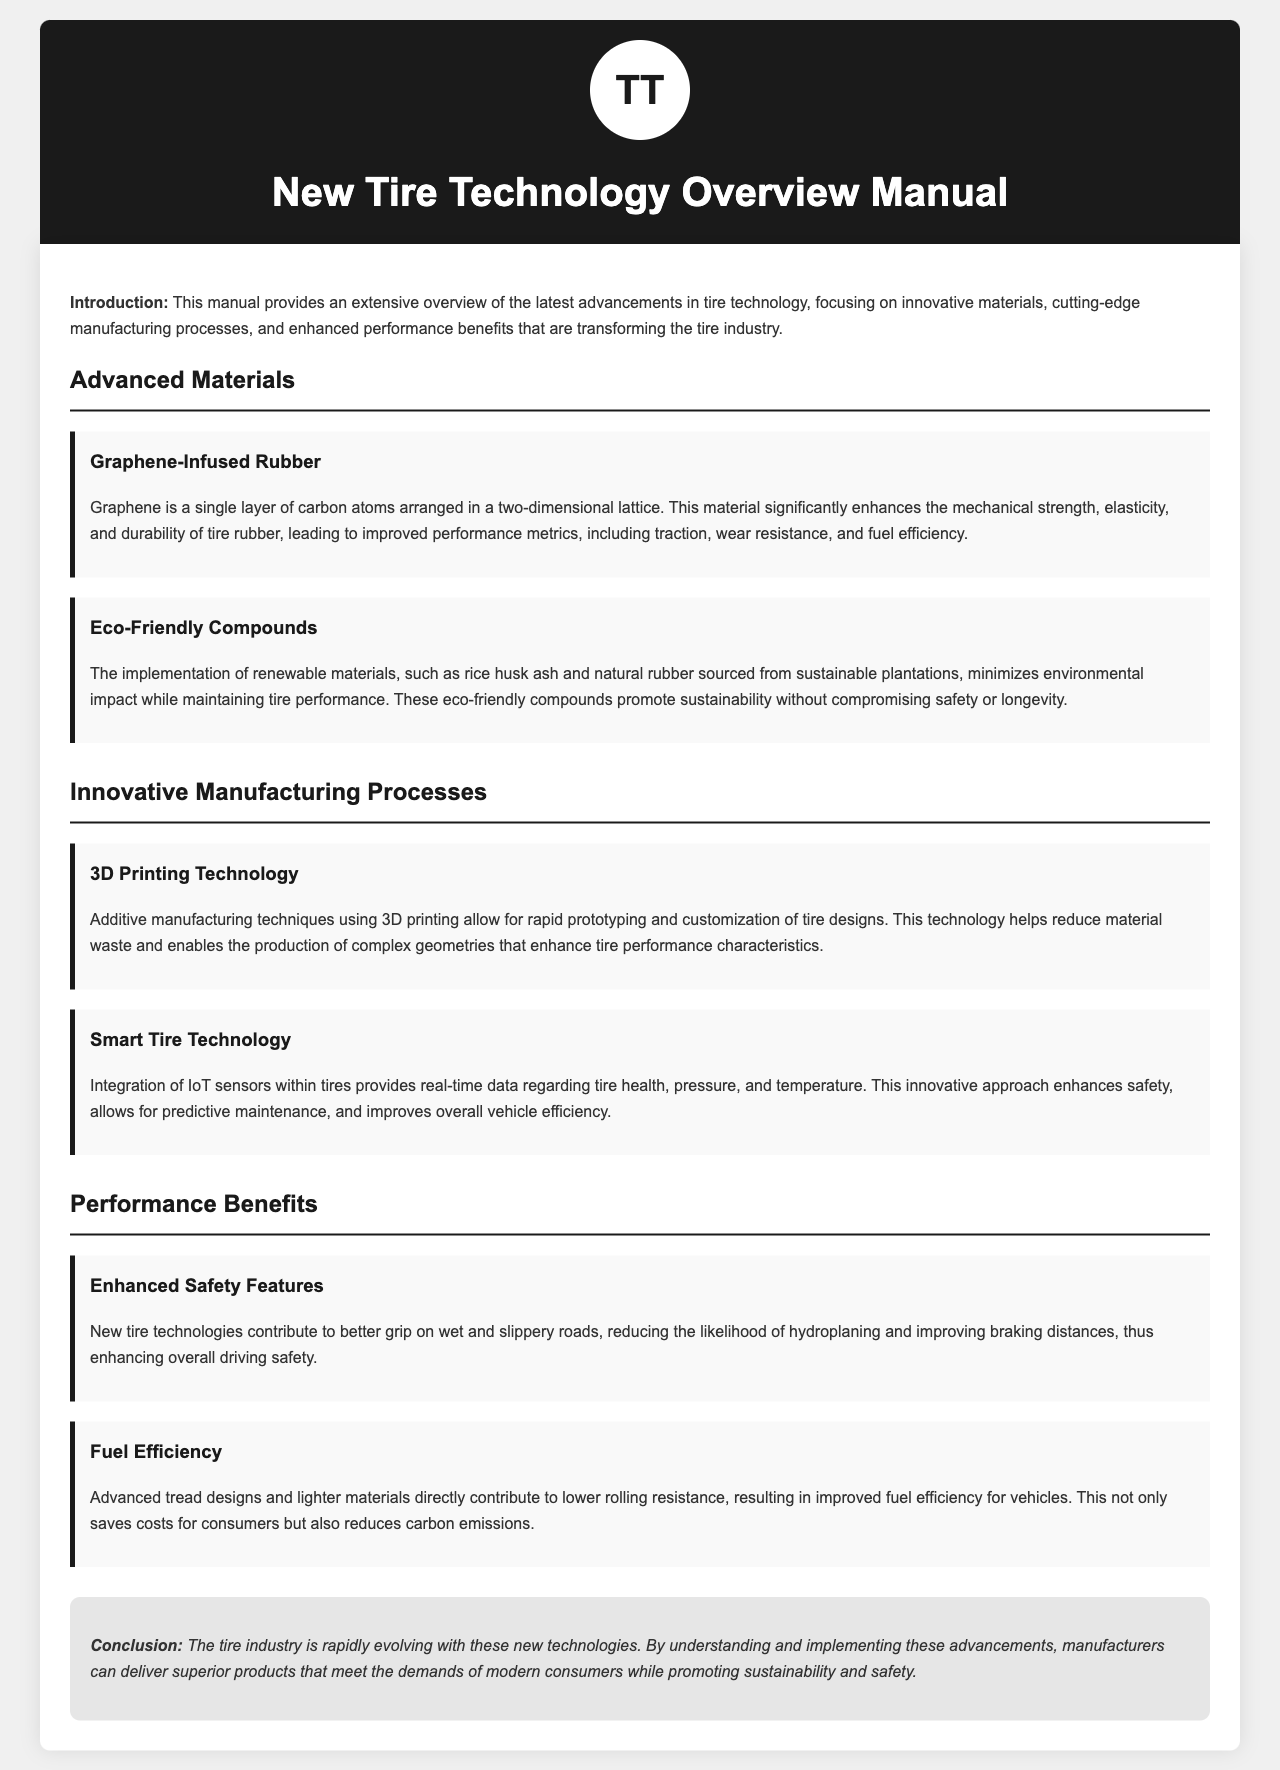What is the focus of the manual? The manual focuses on innovative materials, cutting-edge manufacturing processes, and enhanced performance benefits in tire technology.
Answer: Tire technology What material significantly enhances tire rubber's properties? Graphene is highlighted as a material that significantly enhances mechanical strength, elasticity, and durability of tire rubber.
Answer: Graphene What is one of the eco-friendly materials mentioned? The document mentions rice husk ash as an eco-friendly material used in tire production.
Answer: Rice husk ash What technology allows for rapid prototyping of tire designs? The manual describes additive manufacturing techniques using 3D printing as enabling rapid prototyping.
Answer: 3D printing What is integrated into tires for real-time data monitoring? IoT sensors are integrated into tires to provide real-time data regarding tire health, pressure, and temperature.
Answer: IoT sensors What performance benefit does the new tire technology enhance? One performance benefit of new tire technology is improved grip on wet and slippery roads, which enhances overall driving safety.
Answer: Safety How do advanced tread designs affect fuel efficiency? Advanced tread designs contribute to lower rolling resistance, which improves fuel efficiency for vehicles.
Answer: Lower rolling resistance What is the key conclusion of the manual? The manual concludes that new technologies in the tire industry allow manufacturers to deliver superior products that meet modern consumer demands.
Answer: Superior products Which section covers innovative manufacturing processes? The section titled "Innovative Manufacturing Processes" discusses various innovations related to manufacturing tires.
Answer: Innovative Manufacturing Processes 